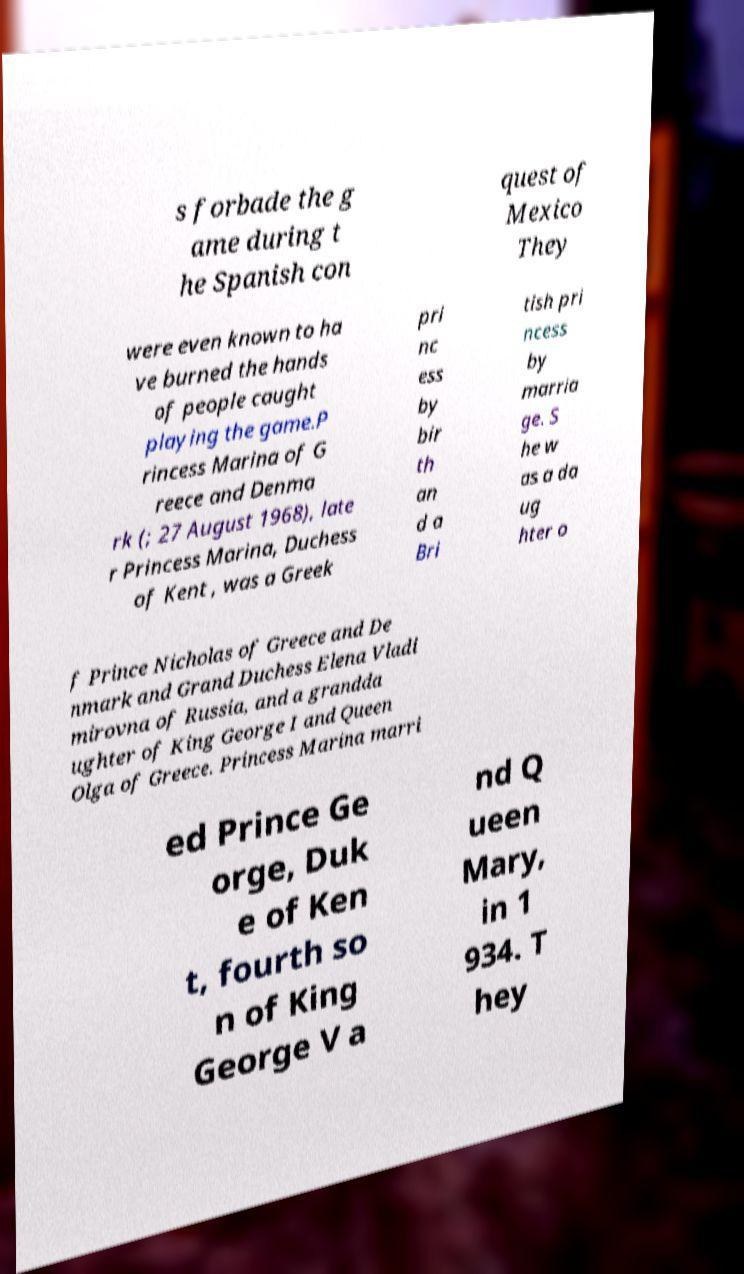Can you accurately transcribe the text from the provided image for me? s forbade the g ame during t he Spanish con quest of Mexico They were even known to ha ve burned the hands of people caught playing the game.P rincess Marina of G reece and Denma rk (; 27 August 1968), late r Princess Marina, Duchess of Kent , was a Greek pri nc ess by bir th an d a Bri tish pri ncess by marria ge. S he w as a da ug hter o f Prince Nicholas of Greece and De nmark and Grand Duchess Elena Vladi mirovna of Russia, and a grandda ughter of King George I and Queen Olga of Greece. Princess Marina marri ed Prince Ge orge, Duk e of Ken t, fourth so n of King George V a nd Q ueen Mary, in 1 934. T hey 